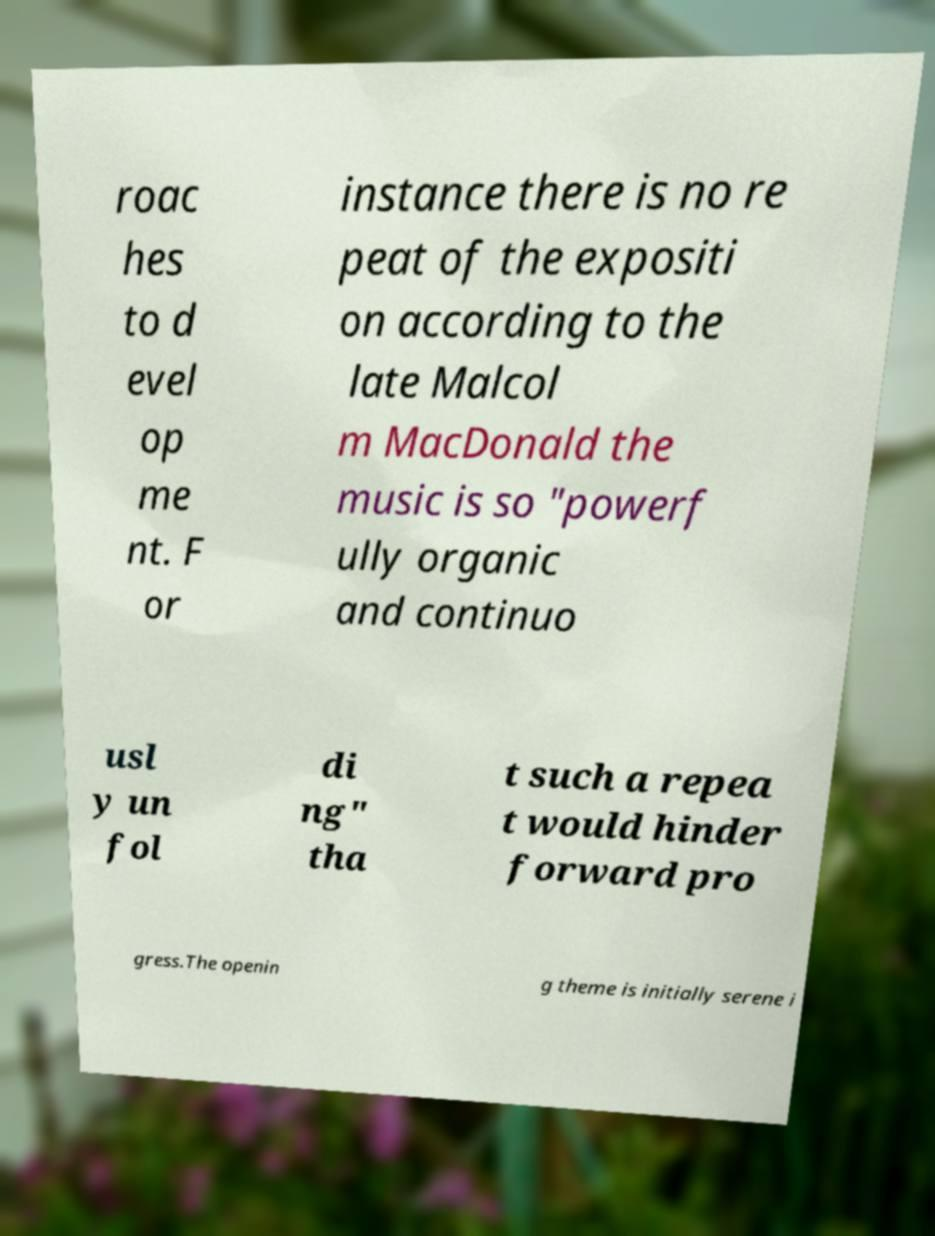Could you extract and type out the text from this image? roac hes to d evel op me nt. F or instance there is no re peat of the expositi on according to the late Malcol m MacDonald the music is so "powerf ully organic and continuo usl y un fol di ng" tha t such a repea t would hinder forward pro gress.The openin g theme is initially serene i 